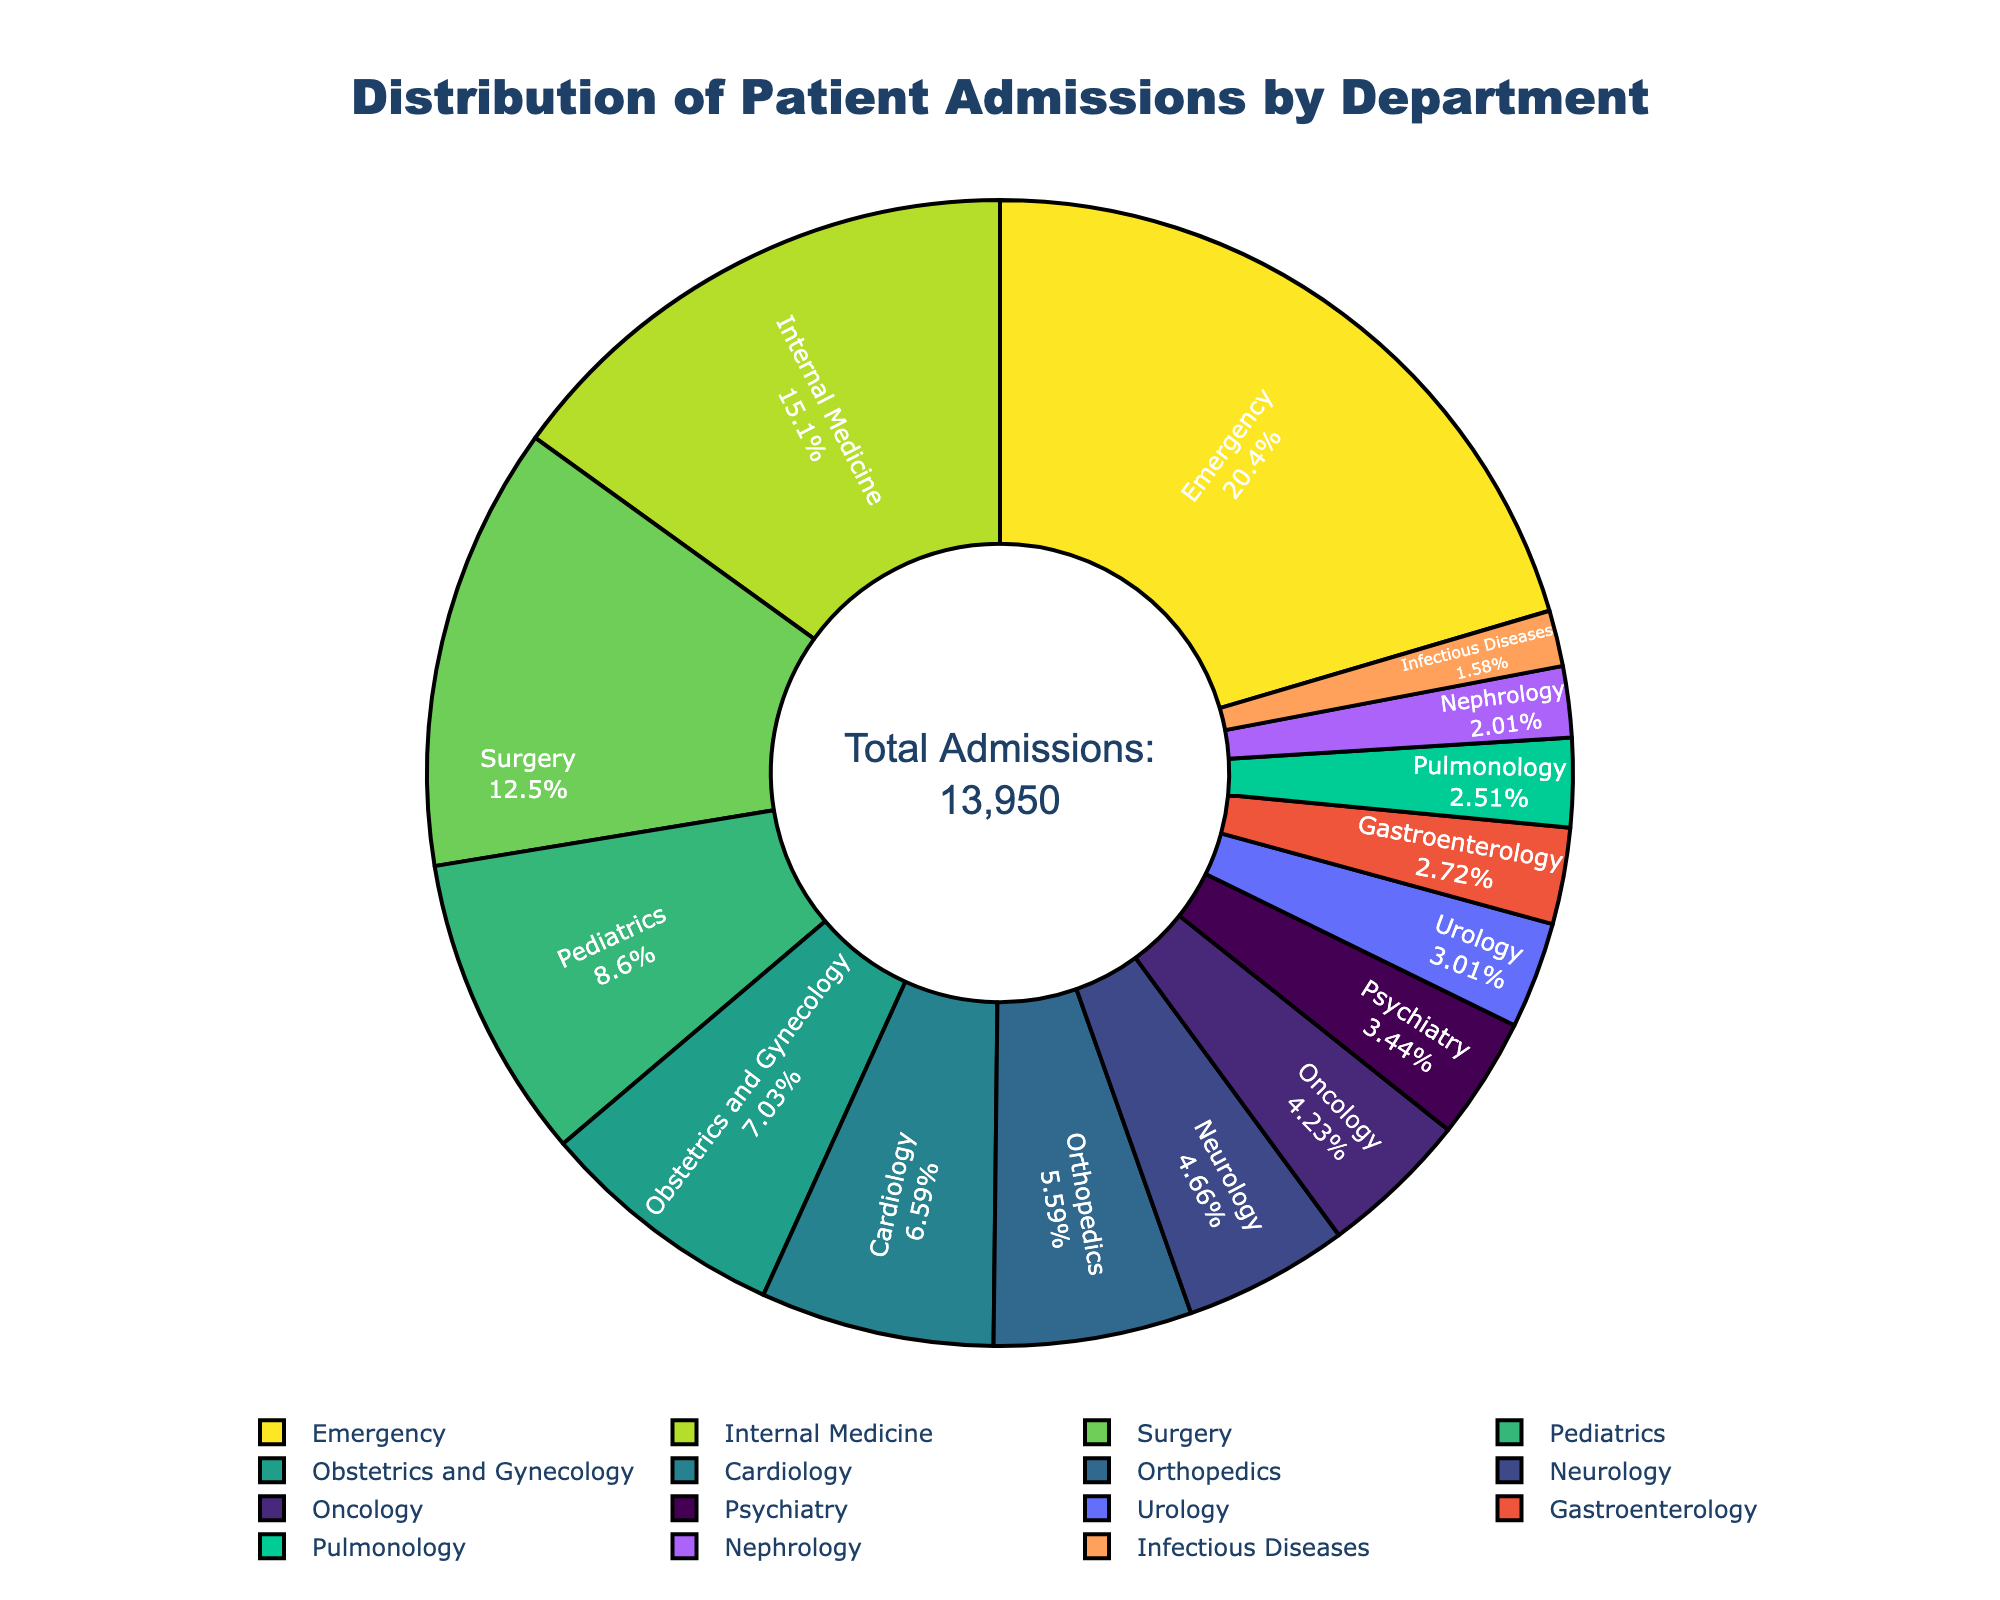What percentage of patient admissions does the Emergency department constitute? The Emergency department's admissions are highlighted in the pie chart segment. Note the percentage labeled inside the segment associated with Emergency.“
Answer: 22% Which department has the lowest number of admissions? Identify the smallest segment of the pie chart. Look at the label or hover over the segment to see the department with the least admissions.
Answer: Infectious Diseases How many total admissions were recorded across all departments? Total admissions are annotated at the center of the pie chart. Read the annotation for the total number of admissions.
Answer: 13,850 Which two departments together account for the highest percentage of patient admissions? Find the two largest segments of the pie chart by area. Observe their respective percentages and sum them up.
Answer: Emergency and Internal Medicine Compare the admissions of Surgery and Cardiology departments. Which has more? Analyze the pie chart segments for Surgery and Cardiology. Note their percentages or values to determine which is larger.
Answer: Surgery If you combined the admissions from Neurology and Psychiatry, would the total be more than the Cardiology department? Find the admissions values from Neurology and Psychiatry on the pie chart, sum them up, and compare their total to Cardiology's admissions.
Answer: No What is the combined percentage of admissions for Pediatrics and Obstetrics and Gynecology? Observe the pie chart segments for Pediatrics and Obstetrics and Gynecology, note their percentages, and add them together.
Answer: 15.7% Which department has a larger number of admissions, Gastroenterology or Pulmonology? Look at the pie chart segments for Gastroenterology and Pulmonology and compare their sizes or percentages.
Answer: Gastroenterology What color represents the Internal Medicine department on the pie chart? Identify the segment labeled Internal Medicine and note its color.
Answer: Yellow How many departments have fewer than 500 admissions? Locate all pie chart segments representing departments with fewer than 500 admissions by observing their value labels and count them.
Answer: Six 